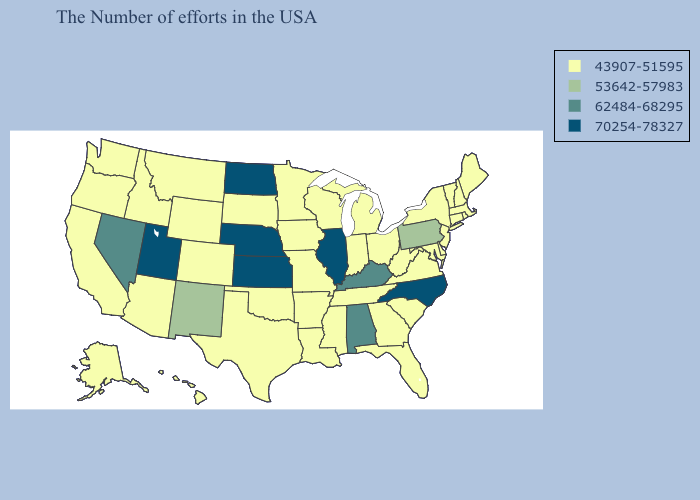How many symbols are there in the legend?
Write a very short answer. 4. Name the states that have a value in the range 62484-68295?
Quick response, please. Kentucky, Alabama, Nevada. Does the map have missing data?
Give a very brief answer. No. Name the states that have a value in the range 62484-68295?
Answer briefly. Kentucky, Alabama, Nevada. Which states have the lowest value in the USA?
Write a very short answer. Maine, Massachusetts, Rhode Island, New Hampshire, Vermont, Connecticut, New York, New Jersey, Delaware, Maryland, Virginia, South Carolina, West Virginia, Ohio, Florida, Georgia, Michigan, Indiana, Tennessee, Wisconsin, Mississippi, Louisiana, Missouri, Arkansas, Minnesota, Iowa, Oklahoma, Texas, South Dakota, Wyoming, Colorado, Montana, Arizona, Idaho, California, Washington, Oregon, Alaska, Hawaii. Name the states that have a value in the range 70254-78327?
Answer briefly. North Carolina, Illinois, Kansas, Nebraska, North Dakota, Utah. Which states have the lowest value in the USA?
Concise answer only. Maine, Massachusetts, Rhode Island, New Hampshire, Vermont, Connecticut, New York, New Jersey, Delaware, Maryland, Virginia, South Carolina, West Virginia, Ohio, Florida, Georgia, Michigan, Indiana, Tennessee, Wisconsin, Mississippi, Louisiana, Missouri, Arkansas, Minnesota, Iowa, Oklahoma, Texas, South Dakota, Wyoming, Colorado, Montana, Arizona, Idaho, California, Washington, Oregon, Alaska, Hawaii. Does North Carolina have the lowest value in the South?
Write a very short answer. No. Does California have the lowest value in the West?
Keep it brief. Yes. What is the lowest value in the USA?
Concise answer only. 43907-51595. Does South Dakota have the highest value in the MidWest?
Concise answer only. No. Which states have the highest value in the USA?
Write a very short answer. North Carolina, Illinois, Kansas, Nebraska, North Dakota, Utah. How many symbols are there in the legend?
Write a very short answer. 4. What is the value of Rhode Island?
Write a very short answer. 43907-51595. Among the states that border Delaware , does Pennsylvania have the highest value?
Short answer required. Yes. 